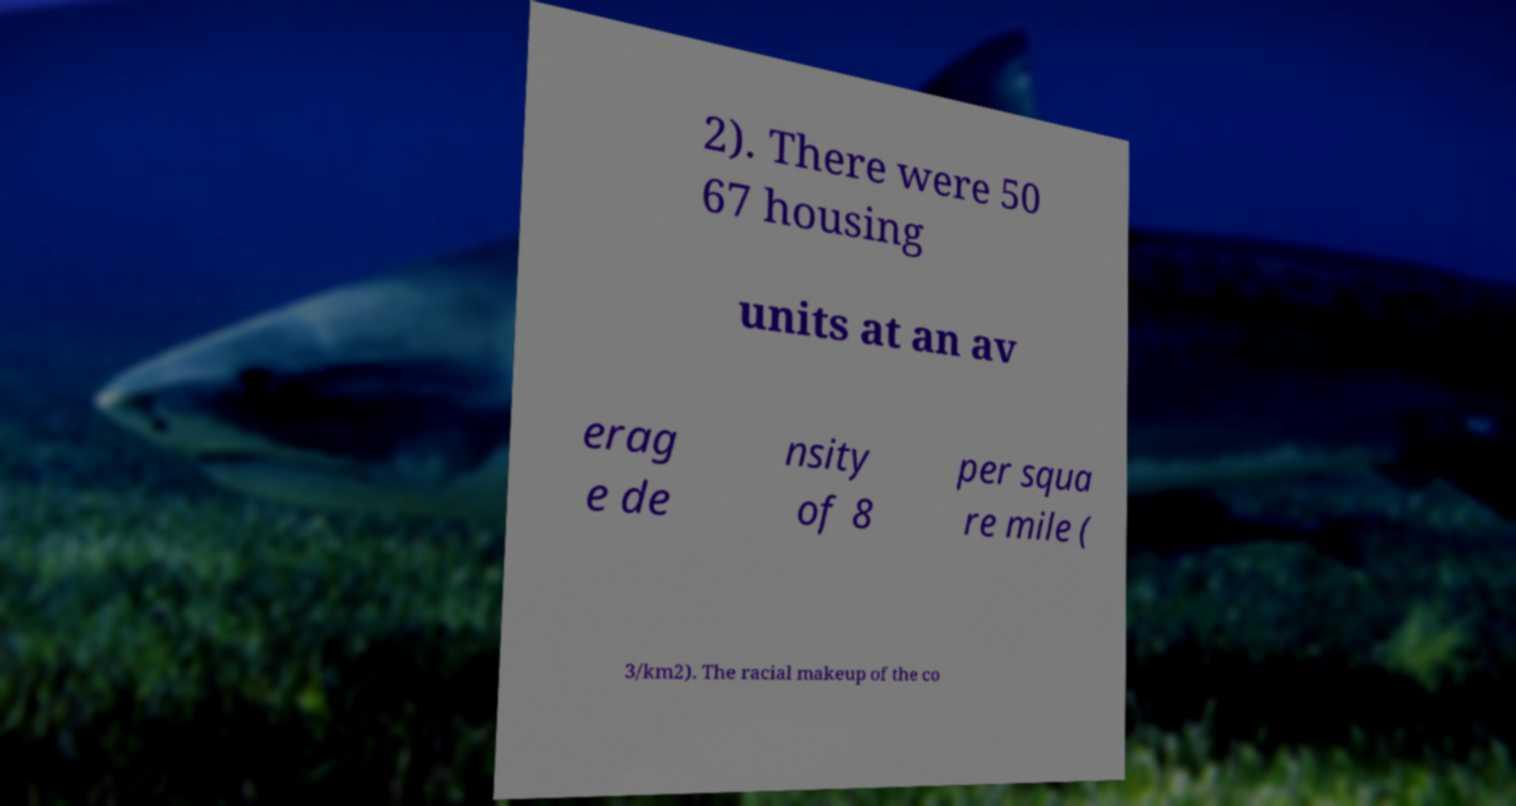I need the written content from this picture converted into text. Can you do that? 2). There were 50 67 housing units at an av erag e de nsity of 8 per squa re mile ( 3/km2). The racial makeup of the co 